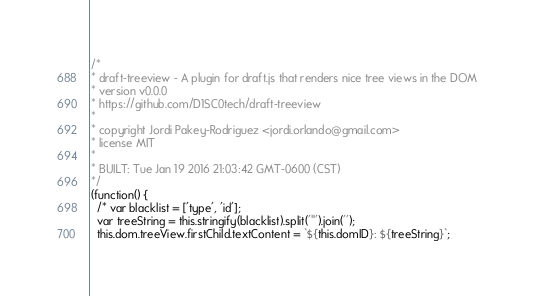Convert code to text. <code><loc_0><loc_0><loc_500><loc_500><_JavaScript_>/*
* draft-treeview - A plugin for draft.js that renders nice tree views in the DOM
* version v0.0.0
* https://github.com/D1SC0tech/draft-treeview
*
* copyright Jordi Pakey-Rodriguez <jordi.orlando@gmail.com>
* license MIT
*
* BUILT: Tue Jan 19 2016 21:03:42 GMT-0600 (CST)
*/
(function() {
  /* var blacklist = ['type', 'id'];
  var treeString = this.stringify(blacklist).split('"').join('');
  this.dom.treeView.firstChild.textContent = `${this.domID}: ${treeString}`;
</code> 